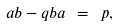<formula> <loc_0><loc_0><loc_500><loc_500>a b - q b a \ = \ p ,</formula> 